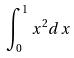Convert formula to latex. <formula><loc_0><loc_0><loc_500><loc_500>\int _ { 0 } ^ { 1 } x ^ { 2 } d x</formula> 